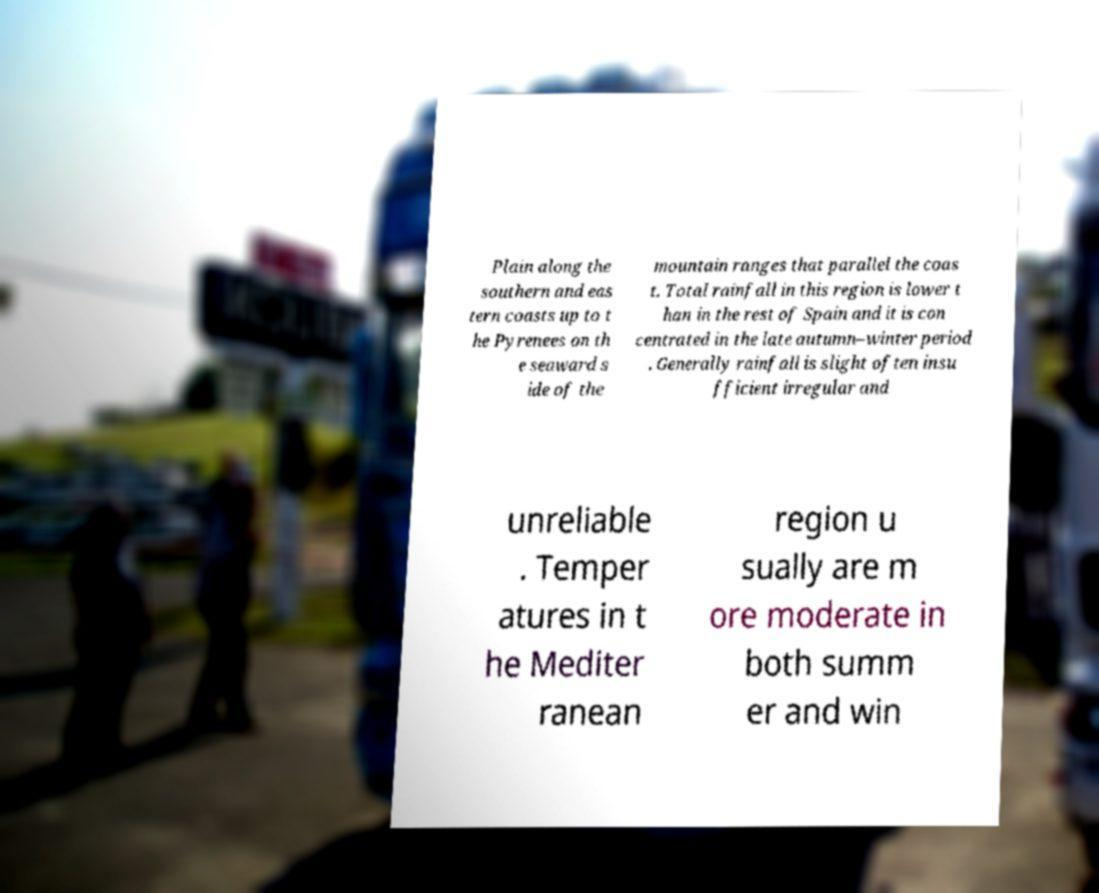Can you accurately transcribe the text from the provided image for me? Plain along the southern and eas tern coasts up to t he Pyrenees on th e seaward s ide of the mountain ranges that parallel the coas t. Total rainfall in this region is lower t han in the rest of Spain and it is con centrated in the late autumn–winter period . Generally rainfall is slight often insu fficient irregular and unreliable . Temper atures in t he Mediter ranean region u sually are m ore moderate in both summ er and win 